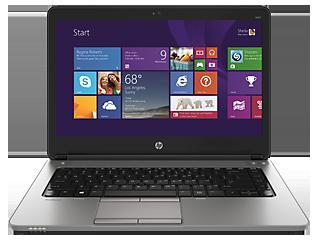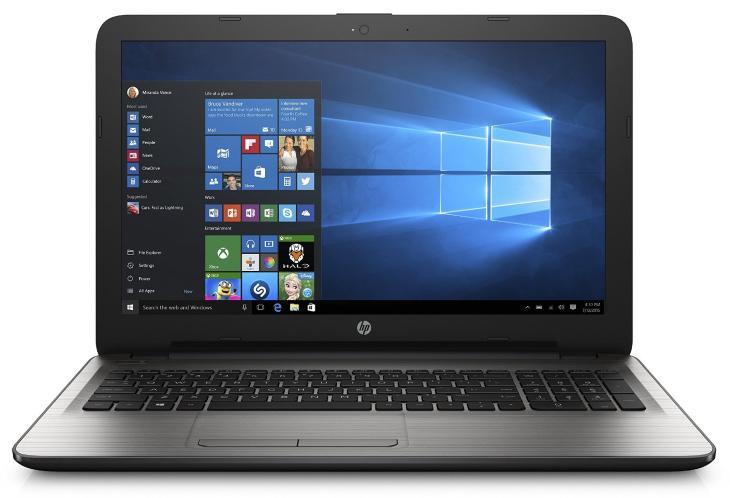The first image is the image on the left, the second image is the image on the right. Examine the images to the left and right. Is the description "Each open laptop is displayed head-on, and each screen contains a square with a black background on the left and glowing blue light that radiates leftward." accurate? Answer yes or no. No. The first image is the image on the left, the second image is the image on the right. Evaluate the accuracy of this statement regarding the images: "Two laptop computers facing front are open with start screens showing, but with different colored keyboards.". Is it true? Answer yes or no. No. 